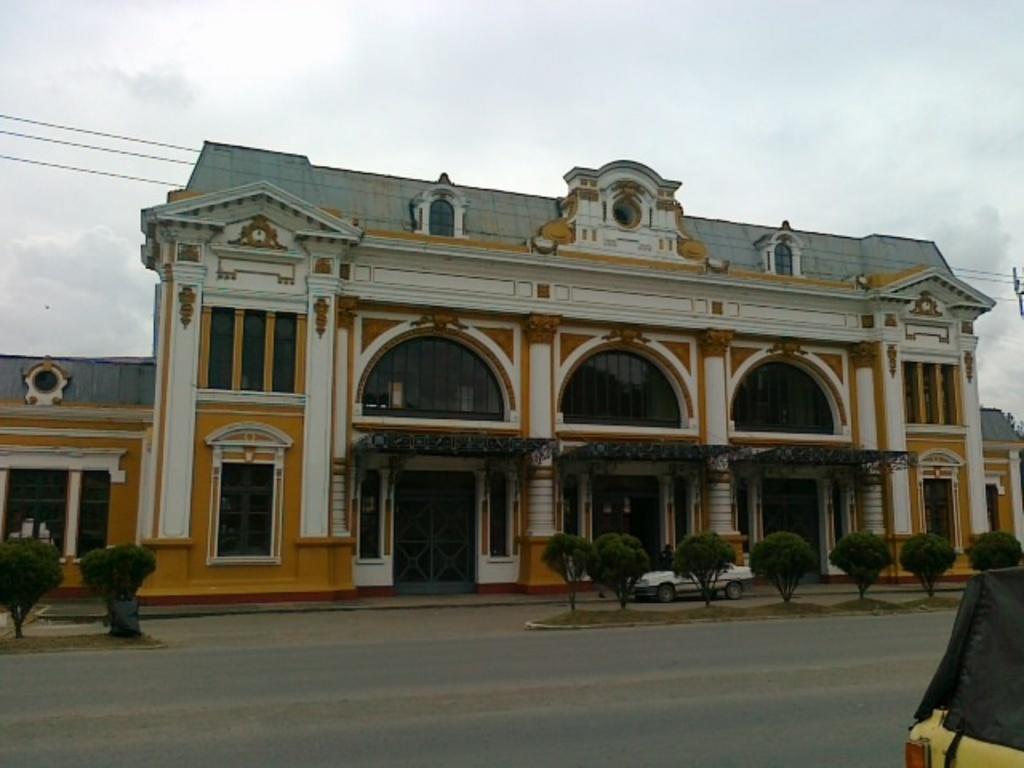Please provide a concise description of this image. In this image in front there is a road. Beside the road there are plants. On the right side of the image there is an object. In the background of the image there is a building. In front of the building there is a car. On top of the image there is sky. 